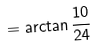<formula> <loc_0><loc_0><loc_500><loc_500>= \arctan { \frac { 1 0 } { 2 4 } }</formula> 